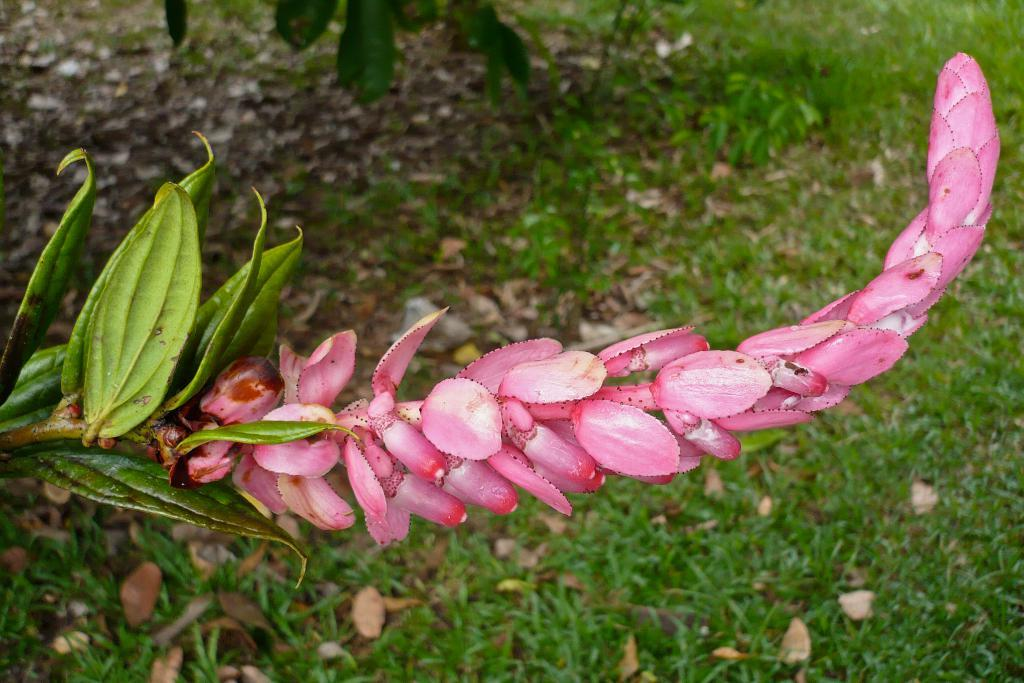What type of plants can be seen in the image? There are flowers, leaves, and grass in the image. Can you describe the natural environment depicted in the image? The image features flowers, leaves, and grass, which are all elements of a natural environment. What type of silk is being used to create the beast in the image? There is no silk or beast present in the image; it features flowers, leaves, and grass. 